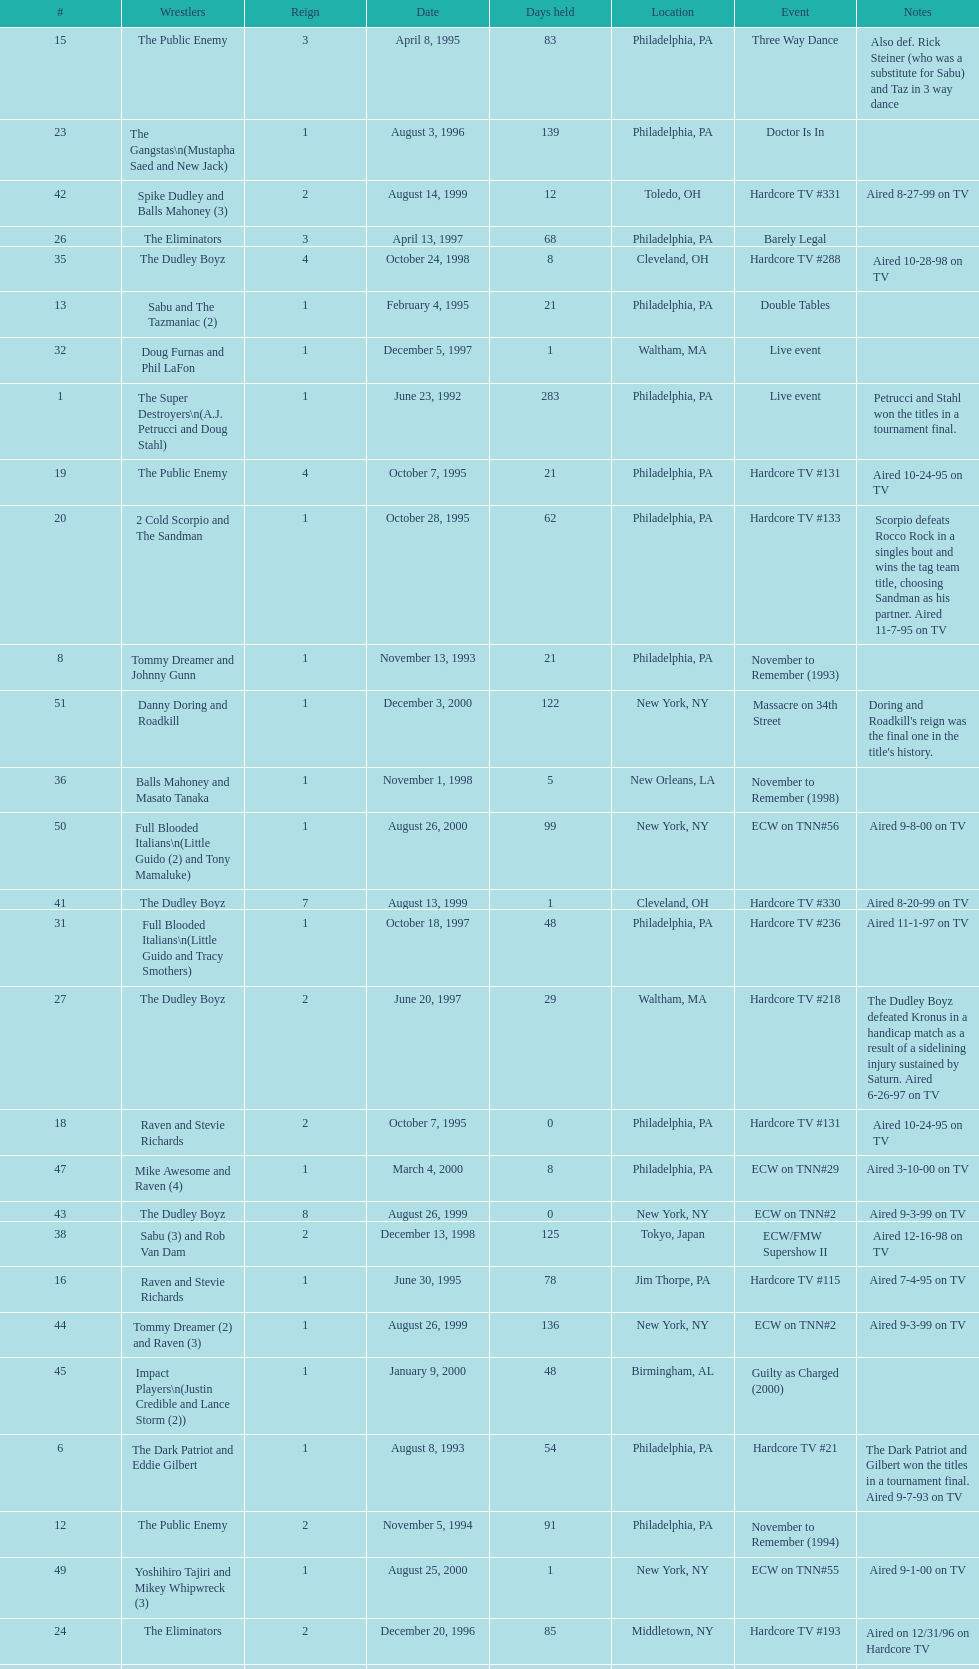Who held the title before the public enemy regained it on april 8th, 1995? Chris Benoit and Dean Malenko. 